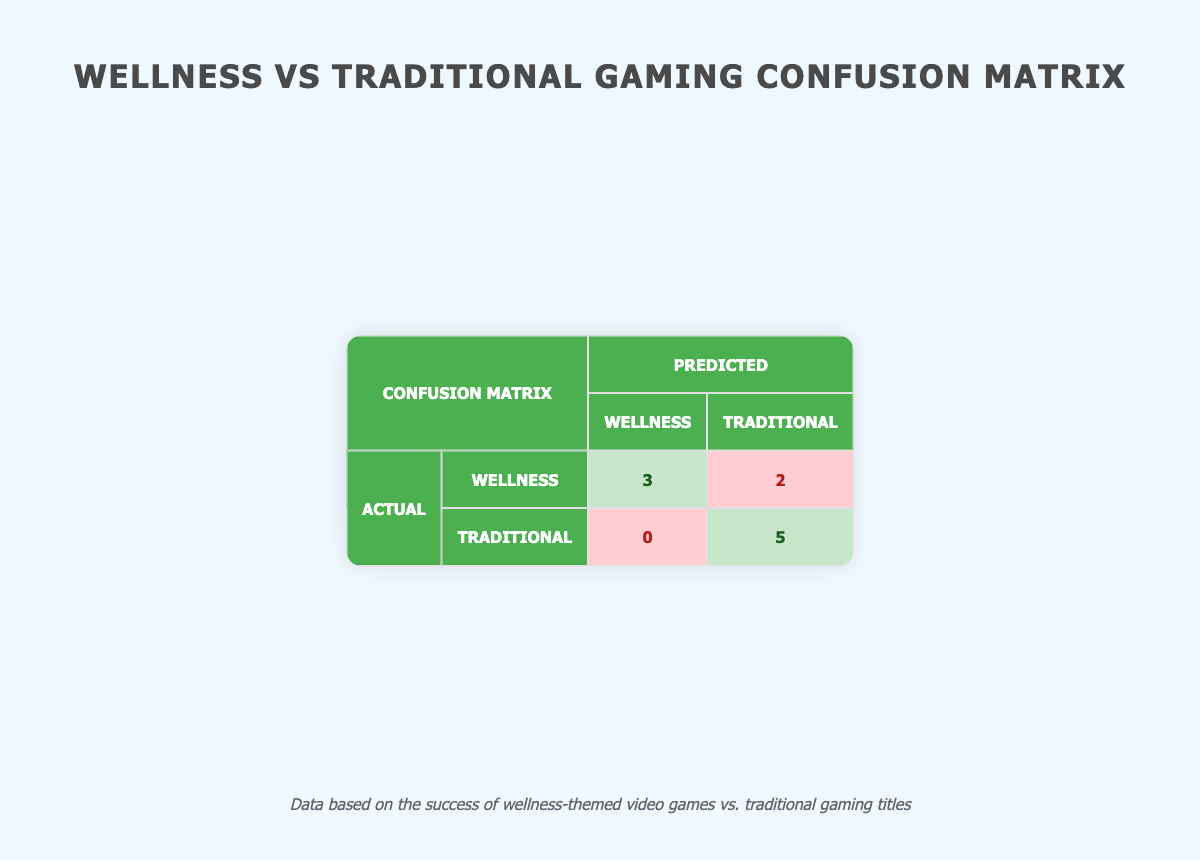What is the number of successful wellness games? From the table, we can see that there are three wellness games that are marked as successful: Ring Fit Adventure, Wii Fit, and Just Dance 2021.
Answer: 3 What is the total number of traditional games represented in the matrix? The table lists five traditional games, which include The Legend of Zelda: Breath of the Wild, Call of Duty: Modern Warfare, Fortnite, Animal Crossing: New Horizons, and Guitar Hero Live.
Answer: 5 Is "Yoga with Adriene: Home" a successful game? According to the table, "Yoga with Adriene: Home" is marked as unsuccessful, indicated by the "successful" field being false.
Answer: No What is the total number of games classified as traditional that are successful? From the five traditional games in the table, four of them are successful: The Legend of Zelda: Breath of the Wild, Call of Duty: Modern Warfare, Fortnite, and Animal Crossing: New Horizons.
Answer: 4 How many unsuccessful wellness games are there? The table shows that there are two wellness games classified as unsuccessful: Yoga with Adriene: Home and Fitness Boxing.
Answer: 2 What is the total number of true positives in the confusion matrix? The table indicates there are three true positives for wellness games, which means three wellness games were correctly classified as successful.
Answer: 3 What is the percentage of traditional games that are successful? Out of the five traditional games, four are successful. The percentage is calculated as (4 successful / 5 total) * 100 = 80%.
Answer: 80% What is the ratio of false negatives to true negatives? The table shows there are 2 false negatives and 5 true negatives. The ratio is 2:5.
Answer: 2:5 Which genre has a higher count of successful games, wellness or traditional? There are three successful wellness games and four successful traditional games. Therefore, traditional games have a higher count of successful games.
Answer: Traditional What is the total number of games that were successfully classified as traditional? According to the table, successful games in the traditional category number four, which are The Legend of Zelda: Breath of the Wild, Call of Duty: Modern Warfare, Fortnite, and Animal Crossing: New Horizons.
Answer: 4 